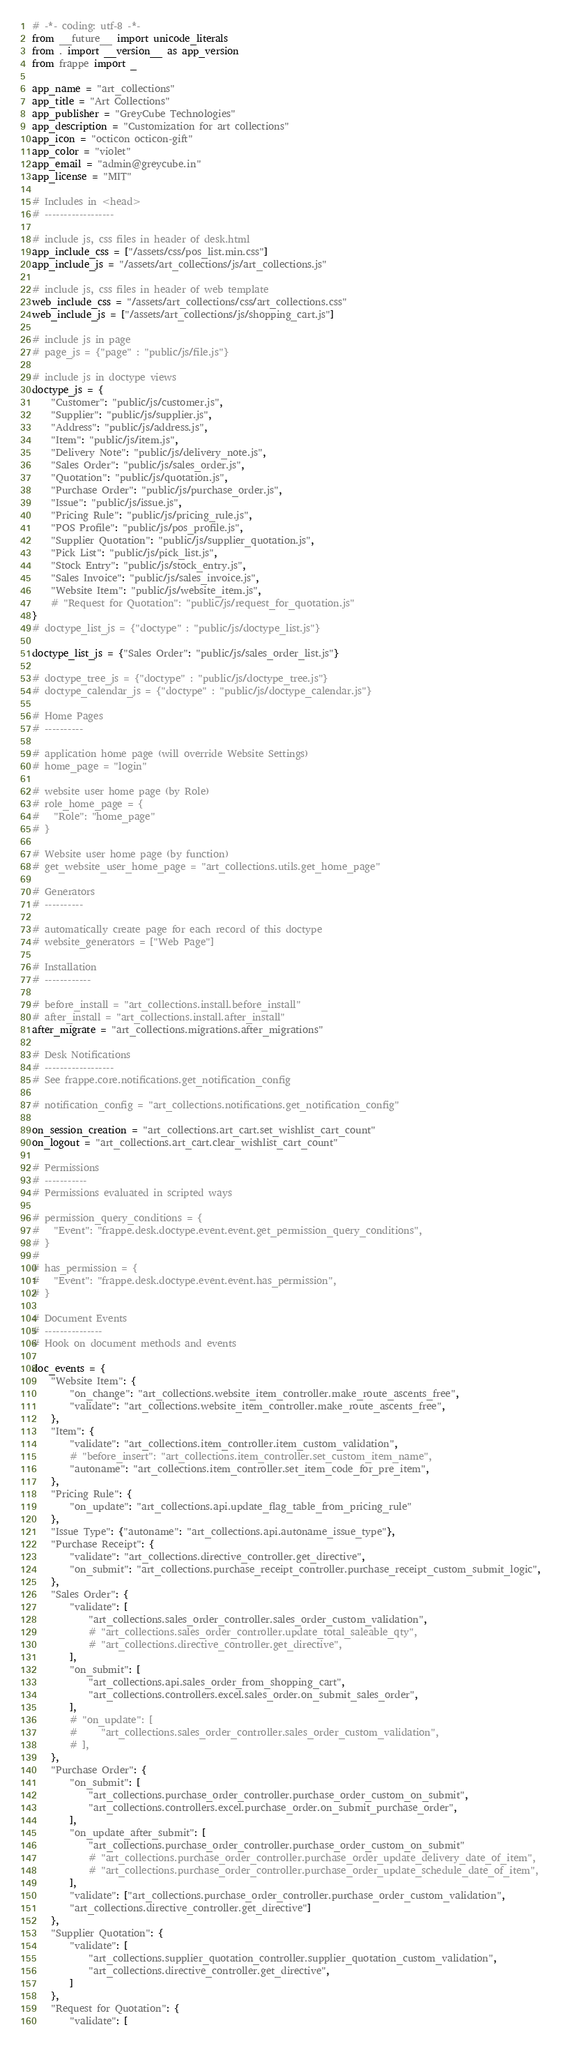<code> <loc_0><loc_0><loc_500><loc_500><_Python_># -*- coding: utf-8 -*-
from __future__ import unicode_literals
from . import __version__ as app_version
from frappe import _

app_name = "art_collections"
app_title = "Art Collections"
app_publisher = "GreyCube Technologies"
app_description = "Customization for art collections"
app_icon = "octicon octicon-gift"
app_color = "violet"
app_email = "admin@greycube.in"
app_license = "MIT"

# Includes in <head>
# ------------------

# include js, css files in header of desk.html
app_include_css = ["/assets/css/pos_list.min.css"]
app_include_js = "/assets/art_collections/js/art_collections.js"

# include js, css files in header of web template
web_include_css = "/assets/art_collections/css/art_collections.css"
web_include_js = ["/assets/art_collections/js/shopping_cart.js"]

# include js in page
# page_js = {"page" : "public/js/file.js"}

# include js in doctype views
doctype_js = {
    "Customer": "public/js/customer.js",
    "Supplier": "public/js/supplier.js",
    "Address": "public/js/address.js",
    "Item": "public/js/item.js",
    "Delivery Note": "public/js/delivery_note.js",
    "Sales Order": "public/js/sales_order.js",
    "Quotation": "public/js/quotation.js",
    "Purchase Order": "public/js/purchase_order.js",
    "Issue": "public/js/issue.js",
    "Pricing Rule": "public/js/pricing_rule.js",
    "POS Profile": "public/js/pos_profile.js",
    "Supplier Quotation": "public/js/supplier_quotation.js",
    "Pick List": "public/js/pick_list.js",
    "Stock Entry": "public/js/stock_entry.js",
    "Sales Invoice": "public/js/sales_invoice.js",
    "Website Item": "public/js/website_item.js",
    # "Request for Quotation": "public/js/request_for_quotation.js"
}
# doctype_list_js = {"doctype" : "public/js/doctype_list.js"}

doctype_list_js = {"Sales Order": "public/js/sales_order_list.js"}

# doctype_tree_js = {"doctype" : "public/js/doctype_tree.js"}
# doctype_calendar_js = {"doctype" : "public/js/doctype_calendar.js"}

# Home Pages
# ----------

# application home page (will override Website Settings)
# home_page = "login"

# website user home page (by Role)
# role_home_page = {
# 	"Role": "home_page"
# }

# Website user home page (by function)
# get_website_user_home_page = "art_collections.utils.get_home_page"

# Generators
# ----------

# automatically create page for each record of this doctype
# website_generators = ["Web Page"]

# Installation
# ------------

# before_install = "art_collections.install.before_install"
# after_install = "art_collections.install.after_install"
after_migrate = "art_collections.migrations.after_migrations"

# Desk Notifications
# ------------------
# See frappe.core.notifications.get_notification_config

# notification_config = "art_collections.notifications.get_notification_config"

on_session_creation = "art_collections.art_cart.set_wishlist_cart_count"
on_logout = "art_collections.art_cart.clear_wishlist_cart_count"

# Permissions
# -----------
# Permissions evaluated in scripted ways

# permission_query_conditions = {
# 	"Event": "frappe.desk.doctype.event.event.get_permission_query_conditions",
# }
#
# has_permission = {
# 	"Event": "frappe.desk.doctype.event.event.has_permission",
# }

# Document Events
# ---------------
# Hook on document methods and events

doc_events = {
    "Website Item": {
        "on_change": "art_collections.website_item_controller.make_route_ascents_free",
        "validate": "art_collections.website_item_controller.make_route_ascents_free",
    },
    "Item": {
        "validate": "art_collections.item_controller.item_custom_validation",
        # "before_insert": "art_collections.item_controller.set_custom_item_name",
        "autoname": "art_collections.item_controller.set_item_code_for_pre_item",
    },
    "Pricing Rule": {
        "on_update": "art_collections.api.update_flag_table_from_pricing_rule"
    },
    "Issue Type": {"autoname": "art_collections.api.autoname_issue_type"},
    "Purchase Receipt": {
        "validate": "art_collections.directive_controller.get_directive",
        "on_submit": "art_collections.purchase_receipt_controller.purchase_receipt_custom_submit_logic",
    },
    "Sales Order": {
        "validate": [
            "art_collections.sales_order_controller.sales_order_custom_validation",
            # "art_collections.sales_order_controller.update_total_saleable_qty",
            # "art_collections.directive_controller.get_directive",
        ],
        "on_submit": [
            "art_collections.api.sales_order_from_shopping_cart",
            "art_collections.controllers.excel.sales_order.on_submit_sales_order",
        ],
        # "on_update": [
        #     "art_collections.sales_order_controller.sales_order_custom_validation",
        # ],
    },
    "Purchase Order": {
        "on_submit": [
            "art_collections.purchase_order_controller.purchase_order_custom_on_submit",
            "art_collections.controllers.excel.purchase_order.on_submit_purchase_order",
        ],
        "on_update_after_submit": [
            "art_collections.purchase_order_controller.purchase_order_custom_on_submit"
            # "art_collections.purchase_order_controller.purchase_order_update_delivery_date_of_item",
            # "art_collections.purchase_order_controller.purchase_order_update_schedule_date_of_item",
        ],
        "validate": ["art_collections.purchase_order_controller.purchase_order_custom_validation",
        "art_collections.directive_controller.get_directive"]
    },
    "Supplier Quotation": {
        "validate": [
            "art_collections.supplier_quotation_controller.supplier_quotation_custom_validation",
            "art_collections.directive_controller.get_directive",
        ]
    },
    "Request for Quotation": {
        "validate": [</code> 